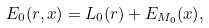<formula> <loc_0><loc_0><loc_500><loc_500>E _ { 0 } ( r , x ) = L _ { 0 } ( r ) + E _ { M _ { 0 } } ( x ) ,</formula> 